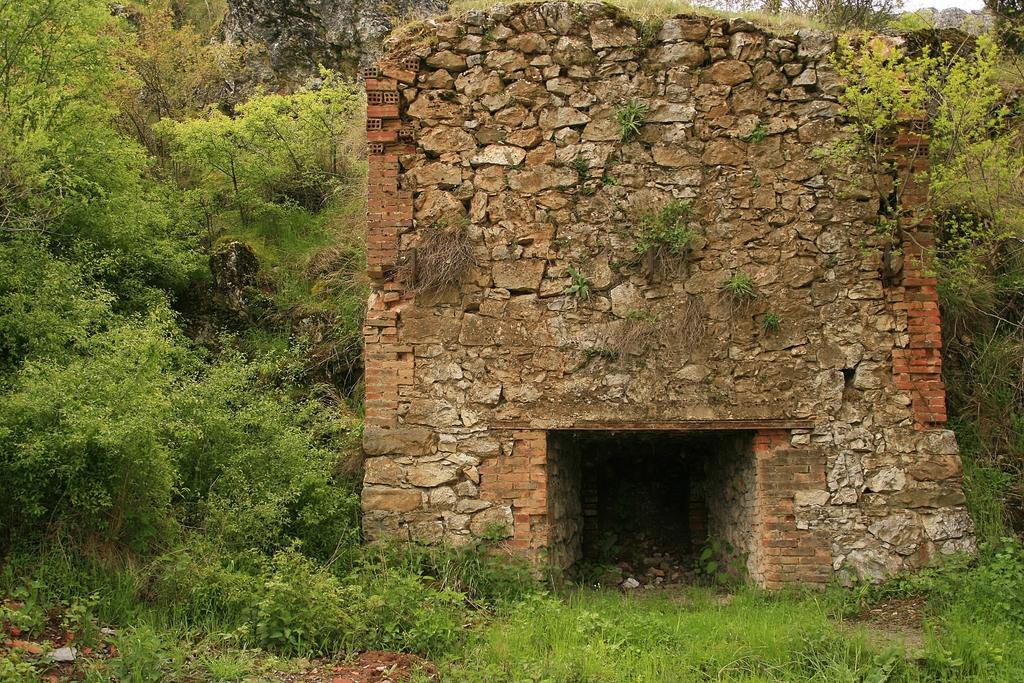What type of natural formation is present in the image? There is a rock structure in the image. What other natural elements can be seen in the image? There are trees and grass in the image. How many chairs are present in the image? There are no chairs visible in the image. What is the relation between the rock structure and the trees in the image? The provided facts do not mention any relation between the rock structure and the trees; they are simply two separate elements in the image. 